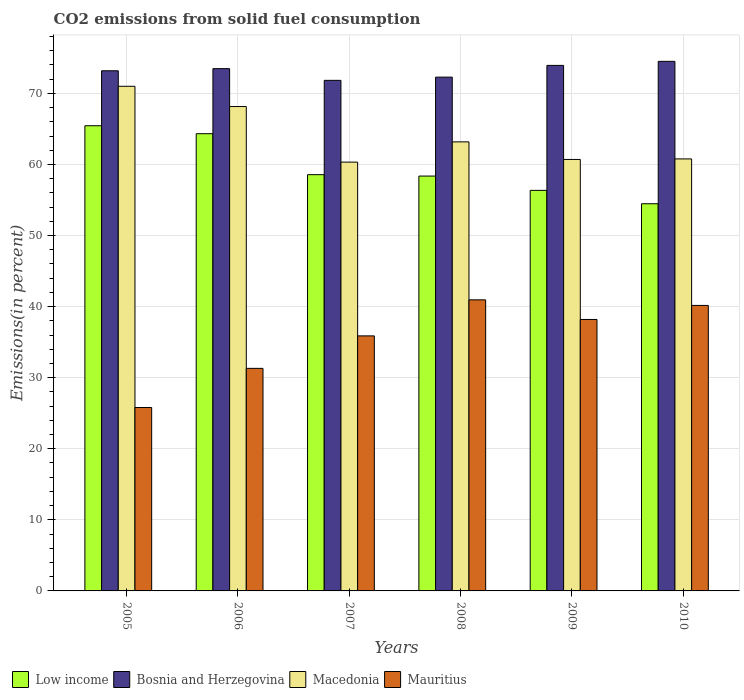How many different coloured bars are there?
Make the answer very short. 4. How many groups of bars are there?
Give a very brief answer. 6. Are the number of bars per tick equal to the number of legend labels?
Offer a very short reply. Yes. What is the label of the 2nd group of bars from the left?
Make the answer very short. 2006. What is the total CO2 emitted in Mauritius in 2009?
Your answer should be very brief. 38.19. Across all years, what is the maximum total CO2 emitted in Mauritius?
Ensure brevity in your answer.  40.95. Across all years, what is the minimum total CO2 emitted in Macedonia?
Provide a short and direct response. 60.33. In which year was the total CO2 emitted in Macedonia maximum?
Keep it short and to the point. 2005. What is the total total CO2 emitted in Mauritius in the graph?
Ensure brevity in your answer.  212.32. What is the difference between the total CO2 emitted in Low income in 2005 and that in 2006?
Ensure brevity in your answer.  1.12. What is the difference between the total CO2 emitted in Macedonia in 2008 and the total CO2 emitted in Bosnia and Herzegovina in 2010?
Offer a very short reply. -11.33. What is the average total CO2 emitted in Macedonia per year?
Offer a terse response. 64.03. In the year 2009, what is the difference between the total CO2 emitted in Macedonia and total CO2 emitted in Low income?
Offer a very short reply. 4.35. What is the ratio of the total CO2 emitted in Mauritius in 2008 to that in 2010?
Your response must be concise. 1.02. What is the difference between the highest and the second highest total CO2 emitted in Mauritius?
Your answer should be very brief. 0.78. What is the difference between the highest and the lowest total CO2 emitted in Bosnia and Herzegovina?
Your answer should be compact. 2.67. In how many years, is the total CO2 emitted in Bosnia and Herzegovina greater than the average total CO2 emitted in Bosnia and Herzegovina taken over all years?
Ensure brevity in your answer.  3. Is it the case that in every year, the sum of the total CO2 emitted in Low income and total CO2 emitted in Macedonia is greater than the sum of total CO2 emitted in Mauritius and total CO2 emitted in Bosnia and Herzegovina?
Provide a short and direct response. No. What does the 3rd bar from the left in 2005 represents?
Your answer should be compact. Macedonia. What does the 1st bar from the right in 2008 represents?
Give a very brief answer. Mauritius. Is it the case that in every year, the sum of the total CO2 emitted in Low income and total CO2 emitted in Mauritius is greater than the total CO2 emitted in Macedonia?
Your answer should be very brief. Yes. Are all the bars in the graph horizontal?
Provide a succinct answer. No. How many years are there in the graph?
Provide a short and direct response. 6. How are the legend labels stacked?
Your response must be concise. Horizontal. What is the title of the graph?
Your answer should be very brief. CO2 emissions from solid fuel consumption. Does "Pakistan" appear as one of the legend labels in the graph?
Offer a very short reply. No. What is the label or title of the X-axis?
Provide a short and direct response. Years. What is the label or title of the Y-axis?
Your answer should be very brief. Emissions(in percent). What is the Emissions(in percent) of Low income in 2005?
Make the answer very short. 65.45. What is the Emissions(in percent) of Bosnia and Herzegovina in 2005?
Your response must be concise. 73.18. What is the Emissions(in percent) in Macedonia in 2005?
Make the answer very short. 71. What is the Emissions(in percent) in Mauritius in 2005?
Keep it short and to the point. 25.81. What is the Emissions(in percent) of Low income in 2006?
Offer a very short reply. 64.33. What is the Emissions(in percent) of Bosnia and Herzegovina in 2006?
Ensure brevity in your answer.  73.49. What is the Emissions(in percent) of Macedonia in 2006?
Provide a succinct answer. 68.15. What is the Emissions(in percent) of Mauritius in 2006?
Offer a very short reply. 31.31. What is the Emissions(in percent) of Low income in 2007?
Offer a terse response. 58.57. What is the Emissions(in percent) in Bosnia and Herzegovina in 2007?
Your answer should be compact. 71.84. What is the Emissions(in percent) in Macedonia in 2007?
Your answer should be very brief. 60.33. What is the Emissions(in percent) in Mauritius in 2007?
Offer a very short reply. 35.88. What is the Emissions(in percent) in Low income in 2008?
Offer a very short reply. 58.37. What is the Emissions(in percent) of Bosnia and Herzegovina in 2008?
Give a very brief answer. 72.29. What is the Emissions(in percent) in Macedonia in 2008?
Your response must be concise. 63.18. What is the Emissions(in percent) in Mauritius in 2008?
Ensure brevity in your answer.  40.95. What is the Emissions(in percent) of Low income in 2009?
Make the answer very short. 56.36. What is the Emissions(in percent) in Bosnia and Herzegovina in 2009?
Give a very brief answer. 73.94. What is the Emissions(in percent) of Macedonia in 2009?
Offer a very short reply. 60.71. What is the Emissions(in percent) of Mauritius in 2009?
Ensure brevity in your answer.  38.19. What is the Emissions(in percent) of Low income in 2010?
Provide a succinct answer. 54.48. What is the Emissions(in percent) in Bosnia and Herzegovina in 2010?
Offer a terse response. 74.51. What is the Emissions(in percent) of Macedonia in 2010?
Keep it short and to the point. 60.78. What is the Emissions(in percent) in Mauritius in 2010?
Give a very brief answer. 40.17. Across all years, what is the maximum Emissions(in percent) of Low income?
Ensure brevity in your answer.  65.45. Across all years, what is the maximum Emissions(in percent) of Bosnia and Herzegovina?
Give a very brief answer. 74.51. Across all years, what is the maximum Emissions(in percent) in Macedonia?
Provide a short and direct response. 71. Across all years, what is the maximum Emissions(in percent) of Mauritius?
Your answer should be very brief. 40.95. Across all years, what is the minimum Emissions(in percent) in Low income?
Offer a terse response. 54.48. Across all years, what is the minimum Emissions(in percent) of Bosnia and Herzegovina?
Offer a very short reply. 71.84. Across all years, what is the minimum Emissions(in percent) in Macedonia?
Provide a succinct answer. 60.33. Across all years, what is the minimum Emissions(in percent) in Mauritius?
Your response must be concise. 25.81. What is the total Emissions(in percent) of Low income in the graph?
Make the answer very short. 357.55. What is the total Emissions(in percent) of Bosnia and Herzegovina in the graph?
Offer a terse response. 439.25. What is the total Emissions(in percent) of Macedonia in the graph?
Your response must be concise. 384.16. What is the total Emissions(in percent) of Mauritius in the graph?
Give a very brief answer. 212.32. What is the difference between the Emissions(in percent) in Low income in 2005 and that in 2006?
Your response must be concise. 1.12. What is the difference between the Emissions(in percent) of Bosnia and Herzegovina in 2005 and that in 2006?
Keep it short and to the point. -0.3. What is the difference between the Emissions(in percent) of Macedonia in 2005 and that in 2006?
Your answer should be compact. 2.85. What is the difference between the Emissions(in percent) in Mauritius in 2005 and that in 2006?
Provide a succinct answer. -5.51. What is the difference between the Emissions(in percent) in Low income in 2005 and that in 2007?
Your answer should be very brief. 6.88. What is the difference between the Emissions(in percent) of Bosnia and Herzegovina in 2005 and that in 2007?
Your answer should be very brief. 1.35. What is the difference between the Emissions(in percent) in Macedonia in 2005 and that in 2007?
Offer a terse response. 10.67. What is the difference between the Emissions(in percent) in Mauritius in 2005 and that in 2007?
Your answer should be compact. -10.08. What is the difference between the Emissions(in percent) of Low income in 2005 and that in 2008?
Offer a very short reply. 7.08. What is the difference between the Emissions(in percent) of Bosnia and Herzegovina in 2005 and that in 2008?
Provide a succinct answer. 0.89. What is the difference between the Emissions(in percent) of Macedonia in 2005 and that in 2008?
Your response must be concise. 7.82. What is the difference between the Emissions(in percent) of Mauritius in 2005 and that in 2008?
Make the answer very short. -15.15. What is the difference between the Emissions(in percent) in Low income in 2005 and that in 2009?
Offer a terse response. 9.09. What is the difference between the Emissions(in percent) of Bosnia and Herzegovina in 2005 and that in 2009?
Offer a terse response. -0.76. What is the difference between the Emissions(in percent) of Macedonia in 2005 and that in 2009?
Provide a short and direct response. 10.29. What is the difference between the Emissions(in percent) in Mauritius in 2005 and that in 2009?
Provide a succinct answer. -12.39. What is the difference between the Emissions(in percent) of Low income in 2005 and that in 2010?
Offer a terse response. 10.97. What is the difference between the Emissions(in percent) of Bosnia and Herzegovina in 2005 and that in 2010?
Provide a short and direct response. -1.33. What is the difference between the Emissions(in percent) of Macedonia in 2005 and that in 2010?
Give a very brief answer. 10.22. What is the difference between the Emissions(in percent) of Mauritius in 2005 and that in 2010?
Provide a succinct answer. -14.36. What is the difference between the Emissions(in percent) in Low income in 2006 and that in 2007?
Your response must be concise. 5.76. What is the difference between the Emissions(in percent) in Bosnia and Herzegovina in 2006 and that in 2007?
Your response must be concise. 1.65. What is the difference between the Emissions(in percent) of Macedonia in 2006 and that in 2007?
Offer a very short reply. 7.82. What is the difference between the Emissions(in percent) in Mauritius in 2006 and that in 2007?
Make the answer very short. -4.57. What is the difference between the Emissions(in percent) of Low income in 2006 and that in 2008?
Your response must be concise. 5.96. What is the difference between the Emissions(in percent) of Bosnia and Herzegovina in 2006 and that in 2008?
Provide a succinct answer. 1.2. What is the difference between the Emissions(in percent) in Macedonia in 2006 and that in 2008?
Provide a short and direct response. 4.97. What is the difference between the Emissions(in percent) of Mauritius in 2006 and that in 2008?
Provide a succinct answer. -9.64. What is the difference between the Emissions(in percent) in Low income in 2006 and that in 2009?
Provide a short and direct response. 7.97. What is the difference between the Emissions(in percent) of Bosnia and Herzegovina in 2006 and that in 2009?
Your answer should be very brief. -0.46. What is the difference between the Emissions(in percent) in Macedonia in 2006 and that in 2009?
Your answer should be very brief. 7.44. What is the difference between the Emissions(in percent) of Mauritius in 2006 and that in 2009?
Provide a short and direct response. -6.88. What is the difference between the Emissions(in percent) in Low income in 2006 and that in 2010?
Your answer should be very brief. 9.86. What is the difference between the Emissions(in percent) of Bosnia and Herzegovina in 2006 and that in 2010?
Provide a succinct answer. -1.02. What is the difference between the Emissions(in percent) in Macedonia in 2006 and that in 2010?
Your answer should be compact. 7.37. What is the difference between the Emissions(in percent) of Mauritius in 2006 and that in 2010?
Your answer should be very brief. -8.86. What is the difference between the Emissions(in percent) of Low income in 2007 and that in 2008?
Your response must be concise. 0.2. What is the difference between the Emissions(in percent) in Bosnia and Herzegovina in 2007 and that in 2008?
Provide a short and direct response. -0.45. What is the difference between the Emissions(in percent) in Macedonia in 2007 and that in 2008?
Ensure brevity in your answer.  -2.85. What is the difference between the Emissions(in percent) of Mauritius in 2007 and that in 2008?
Make the answer very short. -5.07. What is the difference between the Emissions(in percent) of Low income in 2007 and that in 2009?
Your answer should be very brief. 2.21. What is the difference between the Emissions(in percent) of Bosnia and Herzegovina in 2007 and that in 2009?
Keep it short and to the point. -2.11. What is the difference between the Emissions(in percent) in Macedonia in 2007 and that in 2009?
Ensure brevity in your answer.  -0.38. What is the difference between the Emissions(in percent) in Mauritius in 2007 and that in 2009?
Your answer should be compact. -2.31. What is the difference between the Emissions(in percent) of Low income in 2007 and that in 2010?
Make the answer very short. 4.09. What is the difference between the Emissions(in percent) in Bosnia and Herzegovina in 2007 and that in 2010?
Offer a very short reply. -2.67. What is the difference between the Emissions(in percent) of Macedonia in 2007 and that in 2010?
Your answer should be compact. -0.45. What is the difference between the Emissions(in percent) of Mauritius in 2007 and that in 2010?
Keep it short and to the point. -4.28. What is the difference between the Emissions(in percent) in Low income in 2008 and that in 2009?
Provide a succinct answer. 2.01. What is the difference between the Emissions(in percent) of Bosnia and Herzegovina in 2008 and that in 2009?
Your answer should be compact. -1.65. What is the difference between the Emissions(in percent) of Macedonia in 2008 and that in 2009?
Give a very brief answer. 2.47. What is the difference between the Emissions(in percent) in Mauritius in 2008 and that in 2009?
Your answer should be very brief. 2.76. What is the difference between the Emissions(in percent) of Low income in 2008 and that in 2010?
Your response must be concise. 3.89. What is the difference between the Emissions(in percent) in Bosnia and Herzegovina in 2008 and that in 2010?
Your response must be concise. -2.22. What is the difference between the Emissions(in percent) of Macedonia in 2008 and that in 2010?
Give a very brief answer. 2.4. What is the difference between the Emissions(in percent) of Mauritius in 2008 and that in 2010?
Offer a very short reply. 0.78. What is the difference between the Emissions(in percent) of Low income in 2009 and that in 2010?
Offer a terse response. 1.88. What is the difference between the Emissions(in percent) of Bosnia and Herzegovina in 2009 and that in 2010?
Give a very brief answer. -0.57. What is the difference between the Emissions(in percent) in Macedonia in 2009 and that in 2010?
Offer a very short reply. -0.08. What is the difference between the Emissions(in percent) of Mauritius in 2009 and that in 2010?
Offer a terse response. -1.97. What is the difference between the Emissions(in percent) in Low income in 2005 and the Emissions(in percent) in Bosnia and Herzegovina in 2006?
Your response must be concise. -8.04. What is the difference between the Emissions(in percent) in Low income in 2005 and the Emissions(in percent) in Macedonia in 2006?
Your response must be concise. -2.7. What is the difference between the Emissions(in percent) in Low income in 2005 and the Emissions(in percent) in Mauritius in 2006?
Your answer should be compact. 34.14. What is the difference between the Emissions(in percent) of Bosnia and Herzegovina in 2005 and the Emissions(in percent) of Macedonia in 2006?
Keep it short and to the point. 5.03. What is the difference between the Emissions(in percent) in Bosnia and Herzegovina in 2005 and the Emissions(in percent) in Mauritius in 2006?
Keep it short and to the point. 41.87. What is the difference between the Emissions(in percent) in Macedonia in 2005 and the Emissions(in percent) in Mauritius in 2006?
Give a very brief answer. 39.69. What is the difference between the Emissions(in percent) in Low income in 2005 and the Emissions(in percent) in Bosnia and Herzegovina in 2007?
Your response must be concise. -6.39. What is the difference between the Emissions(in percent) of Low income in 2005 and the Emissions(in percent) of Macedonia in 2007?
Make the answer very short. 5.12. What is the difference between the Emissions(in percent) of Low income in 2005 and the Emissions(in percent) of Mauritius in 2007?
Offer a terse response. 29.57. What is the difference between the Emissions(in percent) in Bosnia and Herzegovina in 2005 and the Emissions(in percent) in Macedonia in 2007?
Your answer should be compact. 12.85. What is the difference between the Emissions(in percent) of Bosnia and Herzegovina in 2005 and the Emissions(in percent) of Mauritius in 2007?
Ensure brevity in your answer.  37.3. What is the difference between the Emissions(in percent) in Macedonia in 2005 and the Emissions(in percent) in Mauritius in 2007?
Provide a succinct answer. 35.12. What is the difference between the Emissions(in percent) of Low income in 2005 and the Emissions(in percent) of Bosnia and Herzegovina in 2008?
Give a very brief answer. -6.84. What is the difference between the Emissions(in percent) of Low income in 2005 and the Emissions(in percent) of Macedonia in 2008?
Your response must be concise. 2.27. What is the difference between the Emissions(in percent) in Low income in 2005 and the Emissions(in percent) in Mauritius in 2008?
Provide a short and direct response. 24.5. What is the difference between the Emissions(in percent) in Bosnia and Herzegovina in 2005 and the Emissions(in percent) in Macedonia in 2008?
Make the answer very short. 10. What is the difference between the Emissions(in percent) in Bosnia and Herzegovina in 2005 and the Emissions(in percent) in Mauritius in 2008?
Offer a terse response. 32.23. What is the difference between the Emissions(in percent) in Macedonia in 2005 and the Emissions(in percent) in Mauritius in 2008?
Give a very brief answer. 30.05. What is the difference between the Emissions(in percent) in Low income in 2005 and the Emissions(in percent) in Bosnia and Herzegovina in 2009?
Provide a short and direct response. -8.49. What is the difference between the Emissions(in percent) of Low income in 2005 and the Emissions(in percent) of Macedonia in 2009?
Make the answer very short. 4.74. What is the difference between the Emissions(in percent) in Low income in 2005 and the Emissions(in percent) in Mauritius in 2009?
Keep it short and to the point. 27.26. What is the difference between the Emissions(in percent) of Bosnia and Herzegovina in 2005 and the Emissions(in percent) of Macedonia in 2009?
Your answer should be compact. 12.48. What is the difference between the Emissions(in percent) of Bosnia and Herzegovina in 2005 and the Emissions(in percent) of Mauritius in 2009?
Your response must be concise. 34.99. What is the difference between the Emissions(in percent) in Macedonia in 2005 and the Emissions(in percent) in Mauritius in 2009?
Provide a short and direct response. 32.81. What is the difference between the Emissions(in percent) of Low income in 2005 and the Emissions(in percent) of Bosnia and Herzegovina in 2010?
Your answer should be very brief. -9.06. What is the difference between the Emissions(in percent) of Low income in 2005 and the Emissions(in percent) of Macedonia in 2010?
Your response must be concise. 4.67. What is the difference between the Emissions(in percent) in Low income in 2005 and the Emissions(in percent) in Mauritius in 2010?
Offer a very short reply. 25.28. What is the difference between the Emissions(in percent) of Bosnia and Herzegovina in 2005 and the Emissions(in percent) of Macedonia in 2010?
Offer a terse response. 12.4. What is the difference between the Emissions(in percent) of Bosnia and Herzegovina in 2005 and the Emissions(in percent) of Mauritius in 2010?
Offer a terse response. 33.02. What is the difference between the Emissions(in percent) of Macedonia in 2005 and the Emissions(in percent) of Mauritius in 2010?
Your answer should be compact. 30.83. What is the difference between the Emissions(in percent) of Low income in 2006 and the Emissions(in percent) of Bosnia and Herzegovina in 2007?
Give a very brief answer. -7.51. What is the difference between the Emissions(in percent) of Low income in 2006 and the Emissions(in percent) of Macedonia in 2007?
Offer a terse response. 4. What is the difference between the Emissions(in percent) in Low income in 2006 and the Emissions(in percent) in Mauritius in 2007?
Ensure brevity in your answer.  28.45. What is the difference between the Emissions(in percent) of Bosnia and Herzegovina in 2006 and the Emissions(in percent) of Macedonia in 2007?
Your response must be concise. 13.15. What is the difference between the Emissions(in percent) of Bosnia and Herzegovina in 2006 and the Emissions(in percent) of Mauritius in 2007?
Make the answer very short. 37.6. What is the difference between the Emissions(in percent) in Macedonia in 2006 and the Emissions(in percent) in Mauritius in 2007?
Your response must be concise. 32.27. What is the difference between the Emissions(in percent) in Low income in 2006 and the Emissions(in percent) in Bosnia and Herzegovina in 2008?
Provide a succinct answer. -7.96. What is the difference between the Emissions(in percent) of Low income in 2006 and the Emissions(in percent) of Macedonia in 2008?
Provide a succinct answer. 1.15. What is the difference between the Emissions(in percent) in Low income in 2006 and the Emissions(in percent) in Mauritius in 2008?
Provide a short and direct response. 23.38. What is the difference between the Emissions(in percent) in Bosnia and Herzegovina in 2006 and the Emissions(in percent) in Macedonia in 2008?
Offer a very short reply. 10.3. What is the difference between the Emissions(in percent) of Bosnia and Herzegovina in 2006 and the Emissions(in percent) of Mauritius in 2008?
Your answer should be very brief. 32.53. What is the difference between the Emissions(in percent) of Macedonia in 2006 and the Emissions(in percent) of Mauritius in 2008?
Offer a very short reply. 27.2. What is the difference between the Emissions(in percent) of Low income in 2006 and the Emissions(in percent) of Bosnia and Herzegovina in 2009?
Your answer should be very brief. -9.61. What is the difference between the Emissions(in percent) of Low income in 2006 and the Emissions(in percent) of Macedonia in 2009?
Ensure brevity in your answer.  3.62. What is the difference between the Emissions(in percent) in Low income in 2006 and the Emissions(in percent) in Mauritius in 2009?
Ensure brevity in your answer.  26.14. What is the difference between the Emissions(in percent) of Bosnia and Herzegovina in 2006 and the Emissions(in percent) of Macedonia in 2009?
Keep it short and to the point. 12.78. What is the difference between the Emissions(in percent) of Bosnia and Herzegovina in 2006 and the Emissions(in percent) of Mauritius in 2009?
Keep it short and to the point. 35.29. What is the difference between the Emissions(in percent) in Macedonia in 2006 and the Emissions(in percent) in Mauritius in 2009?
Provide a short and direct response. 29.96. What is the difference between the Emissions(in percent) in Low income in 2006 and the Emissions(in percent) in Bosnia and Herzegovina in 2010?
Make the answer very short. -10.18. What is the difference between the Emissions(in percent) in Low income in 2006 and the Emissions(in percent) in Macedonia in 2010?
Provide a short and direct response. 3.55. What is the difference between the Emissions(in percent) in Low income in 2006 and the Emissions(in percent) in Mauritius in 2010?
Make the answer very short. 24.16. What is the difference between the Emissions(in percent) in Bosnia and Herzegovina in 2006 and the Emissions(in percent) in Macedonia in 2010?
Provide a succinct answer. 12.7. What is the difference between the Emissions(in percent) in Bosnia and Herzegovina in 2006 and the Emissions(in percent) in Mauritius in 2010?
Provide a succinct answer. 33.32. What is the difference between the Emissions(in percent) in Macedonia in 2006 and the Emissions(in percent) in Mauritius in 2010?
Keep it short and to the point. 27.98. What is the difference between the Emissions(in percent) in Low income in 2007 and the Emissions(in percent) in Bosnia and Herzegovina in 2008?
Give a very brief answer. -13.72. What is the difference between the Emissions(in percent) in Low income in 2007 and the Emissions(in percent) in Macedonia in 2008?
Your answer should be very brief. -4.61. What is the difference between the Emissions(in percent) of Low income in 2007 and the Emissions(in percent) of Mauritius in 2008?
Your answer should be very brief. 17.61. What is the difference between the Emissions(in percent) of Bosnia and Herzegovina in 2007 and the Emissions(in percent) of Macedonia in 2008?
Offer a very short reply. 8.65. What is the difference between the Emissions(in percent) of Bosnia and Herzegovina in 2007 and the Emissions(in percent) of Mauritius in 2008?
Provide a succinct answer. 30.88. What is the difference between the Emissions(in percent) in Macedonia in 2007 and the Emissions(in percent) in Mauritius in 2008?
Your answer should be very brief. 19.38. What is the difference between the Emissions(in percent) in Low income in 2007 and the Emissions(in percent) in Bosnia and Herzegovina in 2009?
Keep it short and to the point. -15.37. What is the difference between the Emissions(in percent) in Low income in 2007 and the Emissions(in percent) in Macedonia in 2009?
Your answer should be compact. -2.14. What is the difference between the Emissions(in percent) of Low income in 2007 and the Emissions(in percent) of Mauritius in 2009?
Offer a terse response. 20.37. What is the difference between the Emissions(in percent) of Bosnia and Herzegovina in 2007 and the Emissions(in percent) of Macedonia in 2009?
Your answer should be compact. 11.13. What is the difference between the Emissions(in percent) of Bosnia and Herzegovina in 2007 and the Emissions(in percent) of Mauritius in 2009?
Give a very brief answer. 33.64. What is the difference between the Emissions(in percent) of Macedonia in 2007 and the Emissions(in percent) of Mauritius in 2009?
Provide a succinct answer. 22.14. What is the difference between the Emissions(in percent) in Low income in 2007 and the Emissions(in percent) in Bosnia and Herzegovina in 2010?
Provide a succinct answer. -15.94. What is the difference between the Emissions(in percent) in Low income in 2007 and the Emissions(in percent) in Macedonia in 2010?
Your answer should be compact. -2.22. What is the difference between the Emissions(in percent) in Low income in 2007 and the Emissions(in percent) in Mauritius in 2010?
Your answer should be compact. 18.4. What is the difference between the Emissions(in percent) of Bosnia and Herzegovina in 2007 and the Emissions(in percent) of Macedonia in 2010?
Give a very brief answer. 11.05. What is the difference between the Emissions(in percent) of Bosnia and Herzegovina in 2007 and the Emissions(in percent) of Mauritius in 2010?
Offer a terse response. 31.67. What is the difference between the Emissions(in percent) of Macedonia in 2007 and the Emissions(in percent) of Mauritius in 2010?
Keep it short and to the point. 20.16. What is the difference between the Emissions(in percent) in Low income in 2008 and the Emissions(in percent) in Bosnia and Herzegovina in 2009?
Provide a succinct answer. -15.57. What is the difference between the Emissions(in percent) of Low income in 2008 and the Emissions(in percent) of Macedonia in 2009?
Your answer should be compact. -2.34. What is the difference between the Emissions(in percent) of Low income in 2008 and the Emissions(in percent) of Mauritius in 2009?
Your answer should be compact. 20.17. What is the difference between the Emissions(in percent) of Bosnia and Herzegovina in 2008 and the Emissions(in percent) of Macedonia in 2009?
Ensure brevity in your answer.  11.58. What is the difference between the Emissions(in percent) in Bosnia and Herzegovina in 2008 and the Emissions(in percent) in Mauritius in 2009?
Offer a terse response. 34.09. What is the difference between the Emissions(in percent) of Macedonia in 2008 and the Emissions(in percent) of Mauritius in 2009?
Ensure brevity in your answer.  24.99. What is the difference between the Emissions(in percent) in Low income in 2008 and the Emissions(in percent) in Bosnia and Herzegovina in 2010?
Keep it short and to the point. -16.14. What is the difference between the Emissions(in percent) in Low income in 2008 and the Emissions(in percent) in Macedonia in 2010?
Make the answer very short. -2.42. What is the difference between the Emissions(in percent) in Low income in 2008 and the Emissions(in percent) in Mauritius in 2010?
Ensure brevity in your answer.  18.2. What is the difference between the Emissions(in percent) in Bosnia and Herzegovina in 2008 and the Emissions(in percent) in Macedonia in 2010?
Your answer should be compact. 11.5. What is the difference between the Emissions(in percent) of Bosnia and Herzegovina in 2008 and the Emissions(in percent) of Mauritius in 2010?
Your response must be concise. 32.12. What is the difference between the Emissions(in percent) of Macedonia in 2008 and the Emissions(in percent) of Mauritius in 2010?
Your response must be concise. 23.01. What is the difference between the Emissions(in percent) in Low income in 2009 and the Emissions(in percent) in Bosnia and Herzegovina in 2010?
Ensure brevity in your answer.  -18.15. What is the difference between the Emissions(in percent) in Low income in 2009 and the Emissions(in percent) in Macedonia in 2010?
Offer a terse response. -4.43. What is the difference between the Emissions(in percent) of Low income in 2009 and the Emissions(in percent) of Mauritius in 2010?
Your response must be concise. 16.19. What is the difference between the Emissions(in percent) of Bosnia and Herzegovina in 2009 and the Emissions(in percent) of Macedonia in 2010?
Offer a very short reply. 13.16. What is the difference between the Emissions(in percent) of Bosnia and Herzegovina in 2009 and the Emissions(in percent) of Mauritius in 2010?
Ensure brevity in your answer.  33.77. What is the difference between the Emissions(in percent) in Macedonia in 2009 and the Emissions(in percent) in Mauritius in 2010?
Offer a terse response. 20.54. What is the average Emissions(in percent) of Low income per year?
Make the answer very short. 59.59. What is the average Emissions(in percent) in Bosnia and Herzegovina per year?
Keep it short and to the point. 73.21. What is the average Emissions(in percent) in Macedonia per year?
Ensure brevity in your answer.  64.03. What is the average Emissions(in percent) of Mauritius per year?
Offer a very short reply. 35.39. In the year 2005, what is the difference between the Emissions(in percent) in Low income and Emissions(in percent) in Bosnia and Herzegovina?
Your answer should be very brief. -7.73. In the year 2005, what is the difference between the Emissions(in percent) of Low income and Emissions(in percent) of Macedonia?
Your response must be concise. -5.55. In the year 2005, what is the difference between the Emissions(in percent) of Low income and Emissions(in percent) of Mauritius?
Ensure brevity in your answer.  39.64. In the year 2005, what is the difference between the Emissions(in percent) of Bosnia and Herzegovina and Emissions(in percent) of Macedonia?
Your answer should be very brief. 2.18. In the year 2005, what is the difference between the Emissions(in percent) in Bosnia and Herzegovina and Emissions(in percent) in Mauritius?
Provide a short and direct response. 47.38. In the year 2005, what is the difference between the Emissions(in percent) in Macedonia and Emissions(in percent) in Mauritius?
Keep it short and to the point. 45.19. In the year 2006, what is the difference between the Emissions(in percent) in Low income and Emissions(in percent) in Bosnia and Herzegovina?
Your answer should be compact. -9.15. In the year 2006, what is the difference between the Emissions(in percent) of Low income and Emissions(in percent) of Macedonia?
Offer a terse response. -3.82. In the year 2006, what is the difference between the Emissions(in percent) in Low income and Emissions(in percent) in Mauritius?
Offer a terse response. 33.02. In the year 2006, what is the difference between the Emissions(in percent) in Bosnia and Herzegovina and Emissions(in percent) in Macedonia?
Ensure brevity in your answer.  5.33. In the year 2006, what is the difference between the Emissions(in percent) in Bosnia and Herzegovina and Emissions(in percent) in Mauritius?
Your response must be concise. 42.17. In the year 2006, what is the difference between the Emissions(in percent) in Macedonia and Emissions(in percent) in Mauritius?
Keep it short and to the point. 36.84. In the year 2007, what is the difference between the Emissions(in percent) of Low income and Emissions(in percent) of Bosnia and Herzegovina?
Offer a very short reply. -13.27. In the year 2007, what is the difference between the Emissions(in percent) of Low income and Emissions(in percent) of Macedonia?
Keep it short and to the point. -1.76. In the year 2007, what is the difference between the Emissions(in percent) in Low income and Emissions(in percent) in Mauritius?
Provide a succinct answer. 22.68. In the year 2007, what is the difference between the Emissions(in percent) in Bosnia and Herzegovina and Emissions(in percent) in Macedonia?
Your answer should be very brief. 11.5. In the year 2007, what is the difference between the Emissions(in percent) in Bosnia and Herzegovina and Emissions(in percent) in Mauritius?
Provide a succinct answer. 35.95. In the year 2007, what is the difference between the Emissions(in percent) in Macedonia and Emissions(in percent) in Mauritius?
Make the answer very short. 24.45. In the year 2008, what is the difference between the Emissions(in percent) in Low income and Emissions(in percent) in Bosnia and Herzegovina?
Ensure brevity in your answer.  -13.92. In the year 2008, what is the difference between the Emissions(in percent) in Low income and Emissions(in percent) in Macedonia?
Offer a terse response. -4.81. In the year 2008, what is the difference between the Emissions(in percent) of Low income and Emissions(in percent) of Mauritius?
Provide a succinct answer. 17.42. In the year 2008, what is the difference between the Emissions(in percent) of Bosnia and Herzegovina and Emissions(in percent) of Macedonia?
Give a very brief answer. 9.11. In the year 2008, what is the difference between the Emissions(in percent) of Bosnia and Herzegovina and Emissions(in percent) of Mauritius?
Your answer should be very brief. 31.34. In the year 2008, what is the difference between the Emissions(in percent) in Macedonia and Emissions(in percent) in Mauritius?
Your answer should be very brief. 22.23. In the year 2009, what is the difference between the Emissions(in percent) in Low income and Emissions(in percent) in Bosnia and Herzegovina?
Give a very brief answer. -17.58. In the year 2009, what is the difference between the Emissions(in percent) of Low income and Emissions(in percent) of Macedonia?
Keep it short and to the point. -4.35. In the year 2009, what is the difference between the Emissions(in percent) in Low income and Emissions(in percent) in Mauritius?
Your answer should be very brief. 18.16. In the year 2009, what is the difference between the Emissions(in percent) of Bosnia and Herzegovina and Emissions(in percent) of Macedonia?
Your answer should be very brief. 13.23. In the year 2009, what is the difference between the Emissions(in percent) of Bosnia and Herzegovina and Emissions(in percent) of Mauritius?
Ensure brevity in your answer.  35.75. In the year 2009, what is the difference between the Emissions(in percent) in Macedonia and Emissions(in percent) in Mauritius?
Offer a terse response. 22.51. In the year 2010, what is the difference between the Emissions(in percent) of Low income and Emissions(in percent) of Bosnia and Herzegovina?
Keep it short and to the point. -20.03. In the year 2010, what is the difference between the Emissions(in percent) in Low income and Emissions(in percent) in Macedonia?
Give a very brief answer. -6.31. In the year 2010, what is the difference between the Emissions(in percent) of Low income and Emissions(in percent) of Mauritius?
Your answer should be compact. 14.31. In the year 2010, what is the difference between the Emissions(in percent) of Bosnia and Herzegovina and Emissions(in percent) of Macedonia?
Give a very brief answer. 13.73. In the year 2010, what is the difference between the Emissions(in percent) in Bosnia and Herzegovina and Emissions(in percent) in Mauritius?
Provide a succinct answer. 34.34. In the year 2010, what is the difference between the Emissions(in percent) of Macedonia and Emissions(in percent) of Mauritius?
Provide a succinct answer. 20.62. What is the ratio of the Emissions(in percent) of Low income in 2005 to that in 2006?
Give a very brief answer. 1.02. What is the ratio of the Emissions(in percent) of Bosnia and Herzegovina in 2005 to that in 2006?
Provide a short and direct response. 1. What is the ratio of the Emissions(in percent) of Macedonia in 2005 to that in 2006?
Your answer should be compact. 1.04. What is the ratio of the Emissions(in percent) of Mauritius in 2005 to that in 2006?
Ensure brevity in your answer.  0.82. What is the ratio of the Emissions(in percent) of Low income in 2005 to that in 2007?
Your answer should be very brief. 1.12. What is the ratio of the Emissions(in percent) of Bosnia and Herzegovina in 2005 to that in 2007?
Offer a terse response. 1.02. What is the ratio of the Emissions(in percent) in Macedonia in 2005 to that in 2007?
Make the answer very short. 1.18. What is the ratio of the Emissions(in percent) in Mauritius in 2005 to that in 2007?
Offer a very short reply. 0.72. What is the ratio of the Emissions(in percent) of Low income in 2005 to that in 2008?
Offer a very short reply. 1.12. What is the ratio of the Emissions(in percent) of Bosnia and Herzegovina in 2005 to that in 2008?
Provide a short and direct response. 1.01. What is the ratio of the Emissions(in percent) of Macedonia in 2005 to that in 2008?
Ensure brevity in your answer.  1.12. What is the ratio of the Emissions(in percent) in Mauritius in 2005 to that in 2008?
Offer a very short reply. 0.63. What is the ratio of the Emissions(in percent) in Low income in 2005 to that in 2009?
Give a very brief answer. 1.16. What is the ratio of the Emissions(in percent) of Macedonia in 2005 to that in 2009?
Ensure brevity in your answer.  1.17. What is the ratio of the Emissions(in percent) of Mauritius in 2005 to that in 2009?
Your answer should be compact. 0.68. What is the ratio of the Emissions(in percent) of Low income in 2005 to that in 2010?
Your answer should be compact. 1.2. What is the ratio of the Emissions(in percent) of Bosnia and Herzegovina in 2005 to that in 2010?
Your response must be concise. 0.98. What is the ratio of the Emissions(in percent) of Macedonia in 2005 to that in 2010?
Give a very brief answer. 1.17. What is the ratio of the Emissions(in percent) of Mauritius in 2005 to that in 2010?
Give a very brief answer. 0.64. What is the ratio of the Emissions(in percent) in Low income in 2006 to that in 2007?
Offer a very short reply. 1.1. What is the ratio of the Emissions(in percent) in Macedonia in 2006 to that in 2007?
Give a very brief answer. 1.13. What is the ratio of the Emissions(in percent) of Mauritius in 2006 to that in 2007?
Your response must be concise. 0.87. What is the ratio of the Emissions(in percent) in Low income in 2006 to that in 2008?
Offer a terse response. 1.1. What is the ratio of the Emissions(in percent) of Bosnia and Herzegovina in 2006 to that in 2008?
Make the answer very short. 1.02. What is the ratio of the Emissions(in percent) in Macedonia in 2006 to that in 2008?
Your response must be concise. 1.08. What is the ratio of the Emissions(in percent) in Mauritius in 2006 to that in 2008?
Make the answer very short. 0.76. What is the ratio of the Emissions(in percent) in Low income in 2006 to that in 2009?
Give a very brief answer. 1.14. What is the ratio of the Emissions(in percent) of Macedonia in 2006 to that in 2009?
Make the answer very short. 1.12. What is the ratio of the Emissions(in percent) in Mauritius in 2006 to that in 2009?
Give a very brief answer. 0.82. What is the ratio of the Emissions(in percent) in Low income in 2006 to that in 2010?
Ensure brevity in your answer.  1.18. What is the ratio of the Emissions(in percent) in Bosnia and Herzegovina in 2006 to that in 2010?
Provide a short and direct response. 0.99. What is the ratio of the Emissions(in percent) in Macedonia in 2006 to that in 2010?
Your answer should be compact. 1.12. What is the ratio of the Emissions(in percent) in Mauritius in 2006 to that in 2010?
Keep it short and to the point. 0.78. What is the ratio of the Emissions(in percent) in Macedonia in 2007 to that in 2008?
Offer a terse response. 0.95. What is the ratio of the Emissions(in percent) of Mauritius in 2007 to that in 2008?
Provide a short and direct response. 0.88. What is the ratio of the Emissions(in percent) of Low income in 2007 to that in 2009?
Your answer should be compact. 1.04. What is the ratio of the Emissions(in percent) of Bosnia and Herzegovina in 2007 to that in 2009?
Your answer should be very brief. 0.97. What is the ratio of the Emissions(in percent) of Macedonia in 2007 to that in 2009?
Provide a short and direct response. 0.99. What is the ratio of the Emissions(in percent) in Mauritius in 2007 to that in 2009?
Offer a very short reply. 0.94. What is the ratio of the Emissions(in percent) of Low income in 2007 to that in 2010?
Your answer should be compact. 1.08. What is the ratio of the Emissions(in percent) in Bosnia and Herzegovina in 2007 to that in 2010?
Your answer should be compact. 0.96. What is the ratio of the Emissions(in percent) of Mauritius in 2007 to that in 2010?
Give a very brief answer. 0.89. What is the ratio of the Emissions(in percent) of Low income in 2008 to that in 2009?
Provide a short and direct response. 1.04. What is the ratio of the Emissions(in percent) of Bosnia and Herzegovina in 2008 to that in 2009?
Keep it short and to the point. 0.98. What is the ratio of the Emissions(in percent) of Macedonia in 2008 to that in 2009?
Your answer should be very brief. 1.04. What is the ratio of the Emissions(in percent) in Mauritius in 2008 to that in 2009?
Offer a terse response. 1.07. What is the ratio of the Emissions(in percent) in Low income in 2008 to that in 2010?
Give a very brief answer. 1.07. What is the ratio of the Emissions(in percent) of Bosnia and Herzegovina in 2008 to that in 2010?
Offer a very short reply. 0.97. What is the ratio of the Emissions(in percent) of Macedonia in 2008 to that in 2010?
Give a very brief answer. 1.04. What is the ratio of the Emissions(in percent) in Mauritius in 2008 to that in 2010?
Keep it short and to the point. 1.02. What is the ratio of the Emissions(in percent) in Low income in 2009 to that in 2010?
Keep it short and to the point. 1.03. What is the ratio of the Emissions(in percent) of Bosnia and Herzegovina in 2009 to that in 2010?
Your answer should be compact. 0.99. What is the ratio of the Emissions(in percent) in Mauritius in 2009 to that in 2010?
Keep it short and to the point. 0.95. What is the difference between the highest and the second highest Emissions(in percent) in Low income?
Provide a short and direct response. 1.12. What is the difference between the highest and the second highest Emissions(in percent) of Bosnia and Herzegovina?
Your answer should be compact. 0.57. What is the difference between the highest and the second highest Emissions(in percent) of Macedonia?
Offer a terse response. 2.85. What is the difference between the highest and the second highest Emissions(in percent) in Mauritius?
Keep it short and to the point. 0.78. What is the difference between the highest and the lowest Emissions(in percent) of Low income?
Offer a terse response. 10.97. What is the difference between the highest and the lowest Emissions(in percent) of Bosnia and Herzegovina?
Your response must be concise. 2.67. What is the difference between the highest and the lowest Emissions(in percent) of Macedonia?
Your answer should be very brief. 10.67. What is the difference between the highest and the lowest Emissions(in percent) of Mauritius?
Offer a terse response. 15.15. 